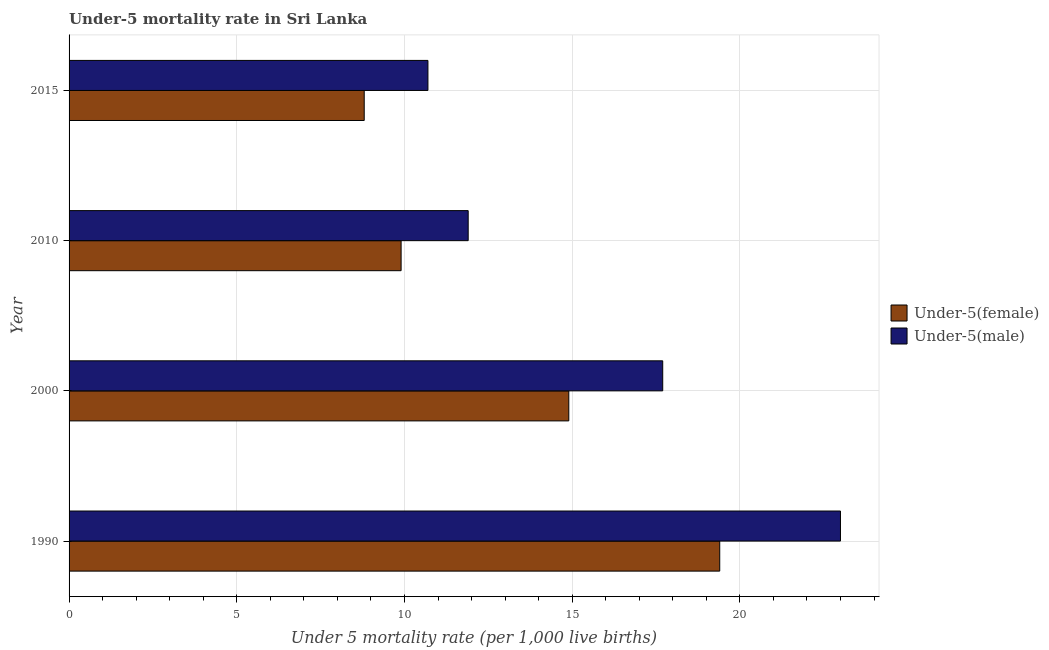How many different coloured bars are there?
Offer a very short reply. 2. How many groups of bars are there?
Your answer should be compact. 4. Are the number of bars per tick equal to the number of legend labels?
Provide a succinct answer. Yes. How many bars are there on the 1st tick from the top?
Offer a very short reply. 2. How many bars are there on the 1st tick from the bottom?
Your answer should be compact. 2. What is the label of the 1st group of bars from the top?
Your answer should be compact. 2015. In how many cases, is the number of bars for a given year not equal to the number of legend labels?
Your response must be concise. 0. In which year was the under-5 male mortality rate minimum?
Provide a succinct answer. 2015. What is the difference between the under-5 female mortality rate in 2000 and that in 2010?
Your answer should be very brief. 5. What is the difference between the under-5 male mortality rate in 1990 and the under-5 female mortality rate in 2010?
Your response must be concise. 13.1. What is the average under-5 female mortality rate per year?
Ensure brevity in your answer.  13.25. In the year 2015, what is the difference between the under-5 female mortality rate and under-5 male mortality rate?
Your answer should be compact. -1.9. What is the ratio of the under-5 male mortality rate in 1990 to that in 2010?
Give a very brief answer. 1.93. Is the difference between the under-5 female mortality rate in 1990 and 2000 greater than the difference between the under-5 male mortality rate in 1990 and 2000?
Provide a succinct answer. No. What is the difference between the highest and the second highest under-5 female mortality rate?
Your response must be concise. 4.5. What is the difference between the highest and the lowest under-5 female mortality rate?
Your answer should be compact. 10.6. Is the sum of the under-5 female mortality rate in 1990 and 2010 greater than the maximum under-5 male mortality rate across all years?
Ensure brevity in your answer.  Yes. What does the 2nd bar from the top in 1990 represents?
Make the answer very short. Under-5(female). What does the 2nd bar from the bottom in 2000 represents?
Offer a very short reply. Under-5(male). How many bars are there?
Make the answer very short. 8. What is the difference between two consecutive major ticks on the X-axis?
Provide a short and direct response. 5. Are the values on the major ticks of X-axis written in scientific E-notation?
Keep it short and to the point. No. Does the graph contain any zero values?
Provide a succinct answer. No. How many legend labels are there?
Offer a very short reply. 2. What is the title of the graph?
Offer a very short reply. Under-5 mortality rate in Sri Lanka. Does "US$" appear as one of the legend labels in the graph?
Offer a very short reply. No. What is the label or title of the X-axis?
Provide a succinct answer. Under 5 mortality rate (per 1,0 live births). What is the label or title of the Y-axis?
Provide a succinct answer. Year. What is the Under 5 mortality rate (per 1,000 live births) in Under-5(female) in 1990?
Your answer should be compact. 19.4. What is the Under 5 mortality rate (per 1,000 live births) in Under-5(male) in 1990?
Your answer should be compact. 23. What is the Under 5 mortality rate (per 1,000 live births) in Under-5(female) in 2000?
Provide a succinct answer. 14.9. What is the Under 5 mortality rate (per 1,000 live births) of Under-5(female) in 2015?
Make the answer very short. 8.8. Across all years, what is the minimum Under 5 mortality rate (per 1,000 live births) in Under-5(female)?
Give a very brief answer. 8.8. What is the total Under 5 mortality rate (per 1,000 live births) in Under-5(female) in the graph?
Your answer should be compact. 53. What is the total Under 5 mortality rate (per 1,000 live births) in Under-5(male) in the graph?
Provide a succinct answer. 63.3. What is the difference between the Under 5 mortality rate (per 1,000 live births) of Under-5(male) in 1990 and that in 2010?
Your answer should be very brief. 11.1. What is the difference between the Under 5 mortality rate (per 1,000 live births) of Under-5(female) in 1990 and that in 2015?
Offer a very short reply. 10.6. What is the difference between the Under 5 mortality rate (per 1,000 live births) of Under-5(female) in 2000 and that in 2015?
Your response must be concise. 6.1. What is the difference between the Under 5 mortality rate (per 1,000 live births) in Under-5(male) in 2000 and that in 2015?
Ensure brevity in your answer.  7. What is the difference between the Under 5 mortality rate (per 1,000 live births) of Under-5(female) in 2010 and that in 2015?
Give a very brief answer. 1.1. What is the difference between the Under 5 mortality rate (per 1,000 live births) of Under-5(male) in 2010 and that in 2015?
Provide a short and direct response. 1.2. What is the difference between the Under 5 mortality rate (per 1,000 live births) in Under-5(female) in 1990 and the Under 5 mortality rate (per 1,000 live births) in Under-5(male) in 2010?
Keep it short and to the point. 7.5. What is the difference between the Under 5 mortality rate (per 1,000 live births) of Under-5(female) in 1990 and the Under 5 mortality rate (per 1,000 live births) of Under-5(male) in 2015?
Offer a terse response. 8.7. What is the difference between the Under 5 mortality rate (per 1,000 live births) in Under-5(female) in 2000 and the Under 5 mortality rate (per 1,000 live births) in Under-5(male) in 2010?
Your answer should be very brief. 3. What is the average Under 5 mortality rate (per 1,000 live births) in Under-5(female) per year?
Your answer should be very brief. 13.25. What is the average Under 5 mortality rate (per 1,000 live births) of Under-5(male) per year?
Your answer should be compact. 15.82. In the year 2015, what is the difference between the Under 5 mortality rate (per 1,000 live births) of Under-5(female) and Under 5 mortality rate (per 1,000 live births) of Under-5(male)?
Offer a terse response. -1.9. What is the ratio of the Under 5 mortality rate (per 1,000 live births) in Under-5(female) in 1990 to that in 2000?
Offer a very short reply. 1.3. What is the ratio of the Under 5 mortality rate (per 1,000 live births) of Under-5(male) in 1990 to that in 2000?
Offer a very short reply. 1.3. What is the ratio of the Under 5 mortality rate (per 1,000 live births) in Under-5(female) in 1990 to that in 2010?
Ensure brevity in your answer.  1.96. What is the ratio of the Under 5 mortality rate (per 1,000 live births) in Under-5(male) in 1990 to that in 2010?
Offer a very short reply. 1.93. What is the ratio of the Under 5 mortality rate (per 1,000 live births) of Under-5(female) in 1990 to that in 2015?
Offer a very short reply. 2.2. What is the ratio of the Under 5 mortality rate (per 1,000 live births) of Under-5(male) in 1990 to that in 2015?
Offer a very short reply. 2.15. What is the ratio of the Under 5 mortality rate (per 1,000 live births) of Under-5(female) in 2000 to that in 2010?
Your answer should be very brief. 1.51. What is the ratio of the Under 5 mortality rate (per 1,000 live births) in Under-5(male) in 2000 to that in 2010?
Your response must be concise. 1.49. What is the ratio of the Under 5 mortality rate (per 1,000 live births) in Under-5(female) in 2000 to that in 2015?
Provide a succinct answer. 1.69. What is the ratio of the Under 5 mortality rate (per 1,000 live births) of Under-5(male) in 2000 to that in 2015?
Your response must be concise. 1.65. What is the ratio of the Under 5 mortality rate (per 1,000 live births) of Under-5(female) in 2010 to that in 2015?
Offer a very short reply. 1.12. What is the ratio of the Under 5 mortality rate (per 1,000 live births) of Under-5(male) in 2010 to that in 2015?
Offer a terse response. 1.11. What is the difference between the highest and the second highest Under 5 mortality rate (per 1,000 live births) in Under-5(female)?
Your response must be concise. 4.5. What is the difference between the highest and the lowest Under 5 mortality rate (per 1,000 live births) in Under-5(female)?
Ensure brevity in your answer.  10.6. 